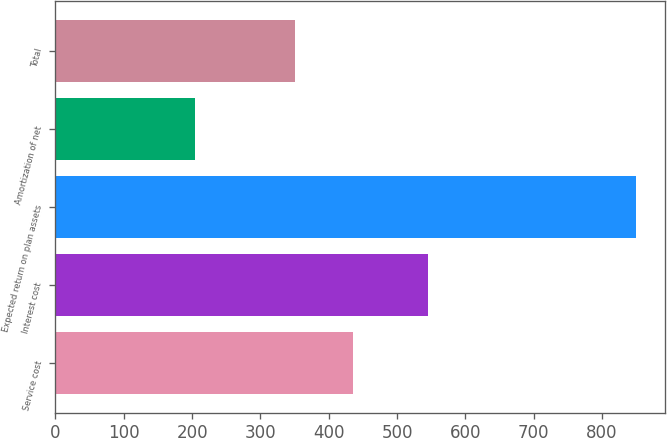<chart> <loc_0><loc_0><loc_500><loc_500><bar_chart><fcel>Service cost<fcel>Interest cost<fcel>Expected return on plan assets<fcel>Amortization of net<fcel>Total<nl><fcel>435<fcel>546<fcel>850<fcel>205<fcel>351<nl></chart> 